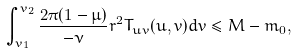Convert formula to latex. <formula><loc_0><loc_0><loc_500><loc_500>\int _ { v _ { 1 } } ^ { v _ { 2 } } \frac { 2 \pi ( 1 - \mu ) } { - \nu } r ^ { 2 } T _ { u v } ( u , v ) d v \leq M - m _ { 0 } ,</formula> 